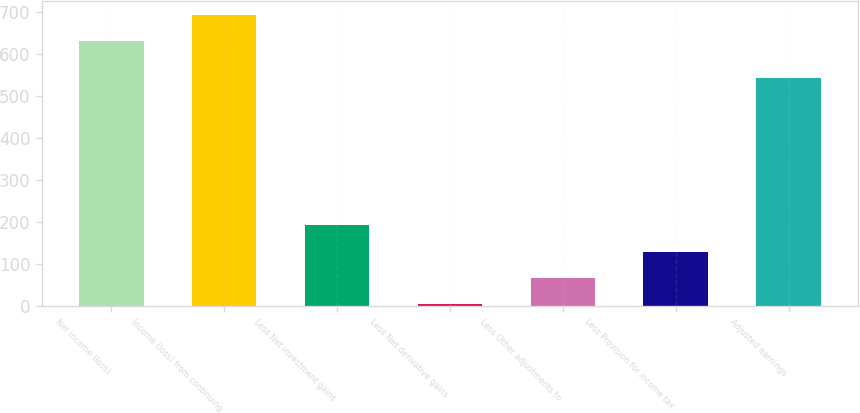<chart> <loc_0><loc_0><loc_500><loc_500><bar_chart><fcel>Net income (loss)<fcel>Income (loss) from continuing<fcel>Less Net investment gains<fcel>Less Net derivative gains<fcel>Less Other adjustments to<fcel>Less Provision for income tax<fcel>Adjusted earnings<nl><fcel>629<fcel>691.6<fcel>190.8<fcel>3<fcel>65.6<fcel>128.2<fcel>543<nl></chart> 